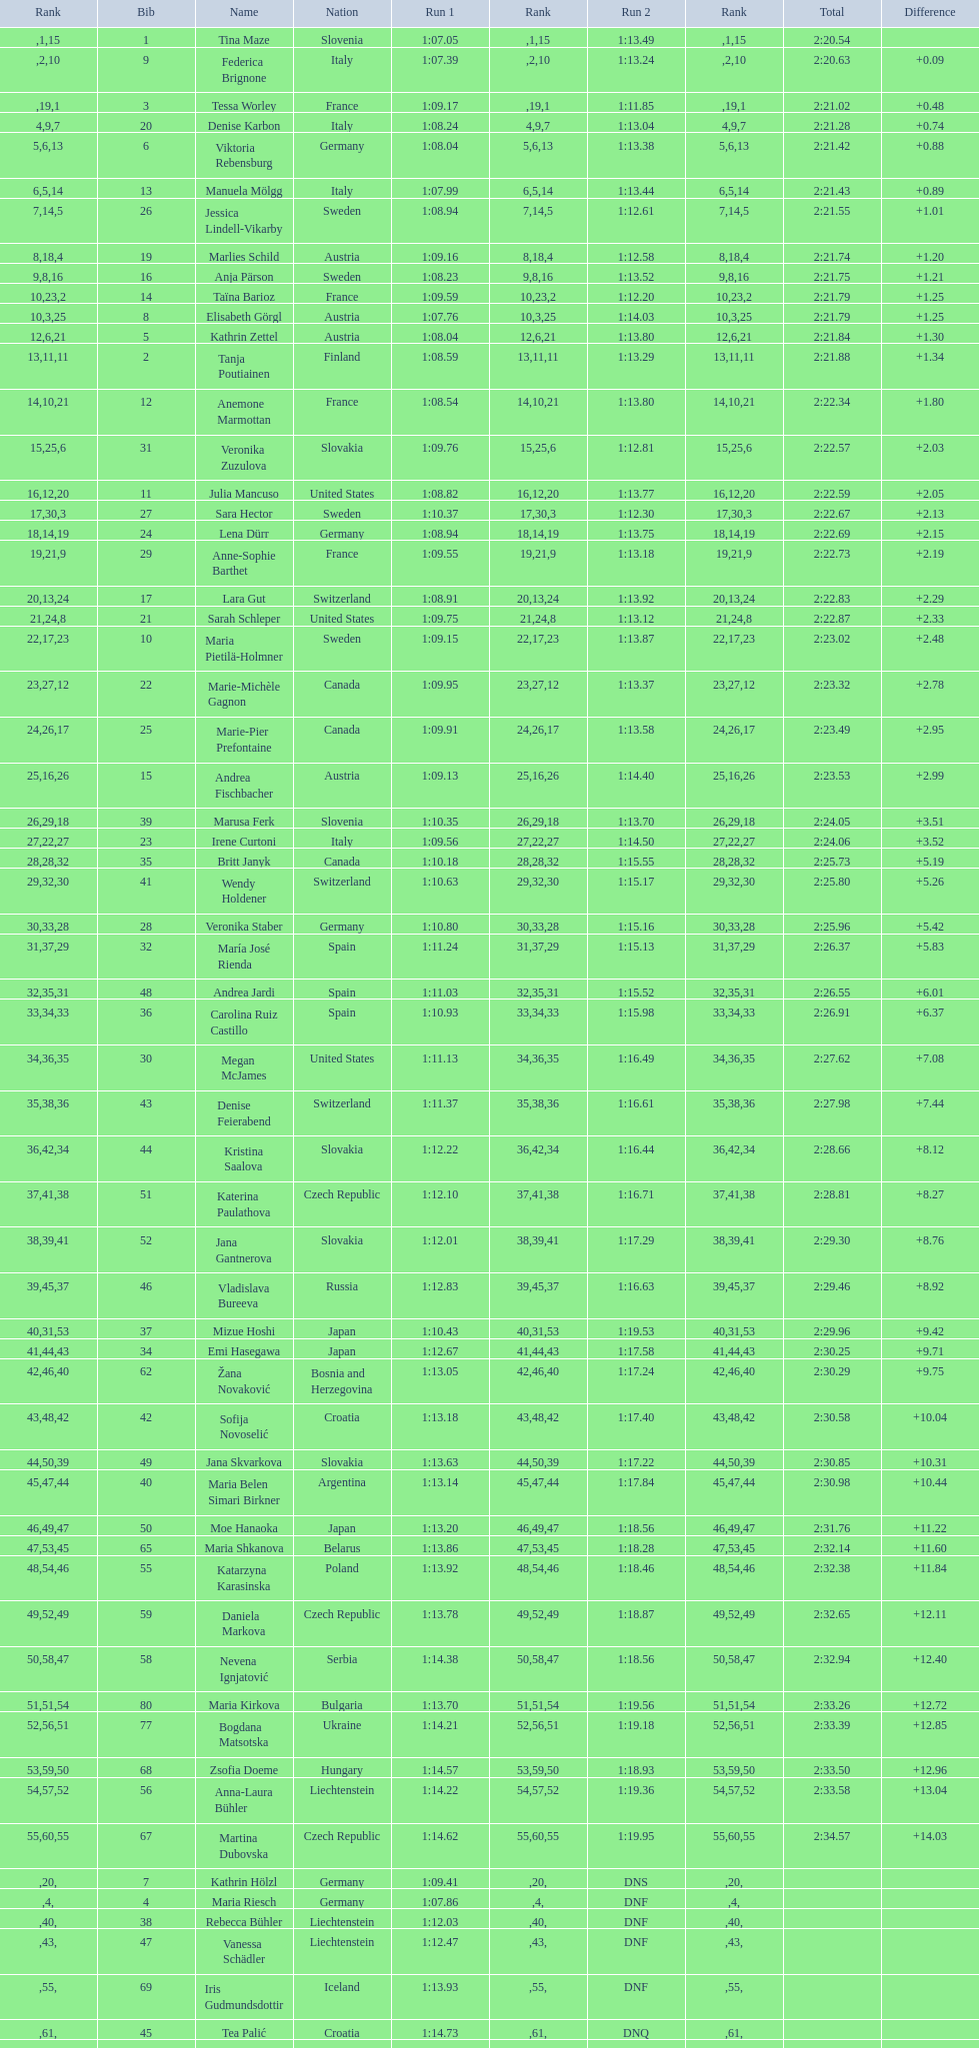What was the quantity of swedes in the top fifteen? 2. 